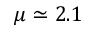Convert formula to latex. <formula><loc_0><loc_0><loc_500><loc_500>\mu \simeq 2 . 1</formula> 